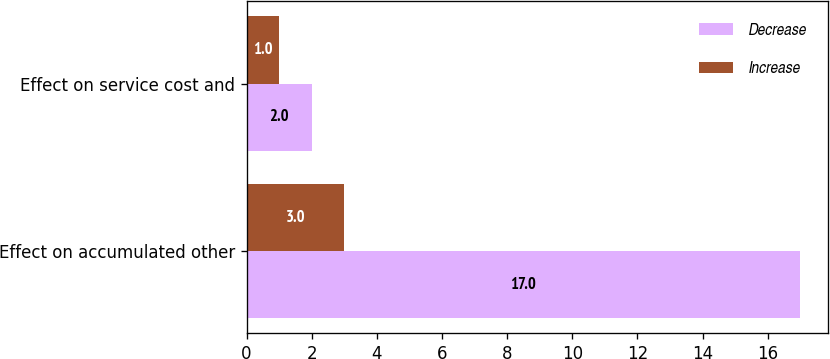Convert chart. <chart><loc_0><loc_0><loc_500><loc_500><stacked_bar_chart><ecel><fcel>Effect on accumulated other<fcel>Effect on service cost and<nl><fcel>Decrease<fcel>17<fcel>2<nl><fcel>Increase<fcel>3<fcel>1<nl></chart> 